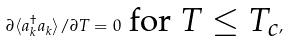<formula> <loc_0><loc_0><loc_500><loc_500>\partial \langle a ^ { \dagger } _ { k } a _ { k } \rangle / \partial T = 0 \text { for $T\leq T_{c}$} ,</formula> 